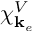<formula> <loc_0><loc_0><loc_500><loc_500>\chi _ { k _ { e } } ^ { V }</formula> 